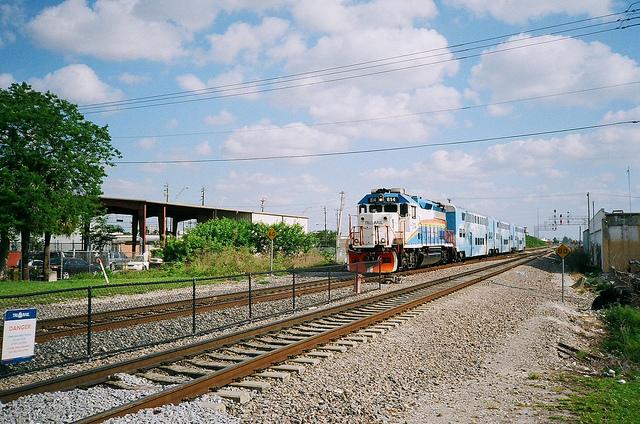Is the train going through the countryside?
Give a very brief answer. No. What is creating the cloud above the train?
Give a very brief answer. Weather. Is this photo taken during the day or night?
Answer briefly. Day. What does the sign in the bottom left corner of picture say?
Answer briefly. Danger. What color is the light on the tracks?
Short answer required. White. How many train tracks is there?
Short answer required. 2. What vegetation is behind the train?
Answer briefly. Trees. Why are there rocks in between the tracks?
Keep it brief. No. How many tracks are visible?
Concise answer only. 2. What color is the train?
Short answer required. Blue and white. How many trees are seen?
Quick response, please. 1. Why is there a gate separating the tracks?
Short answer required. Collision. 